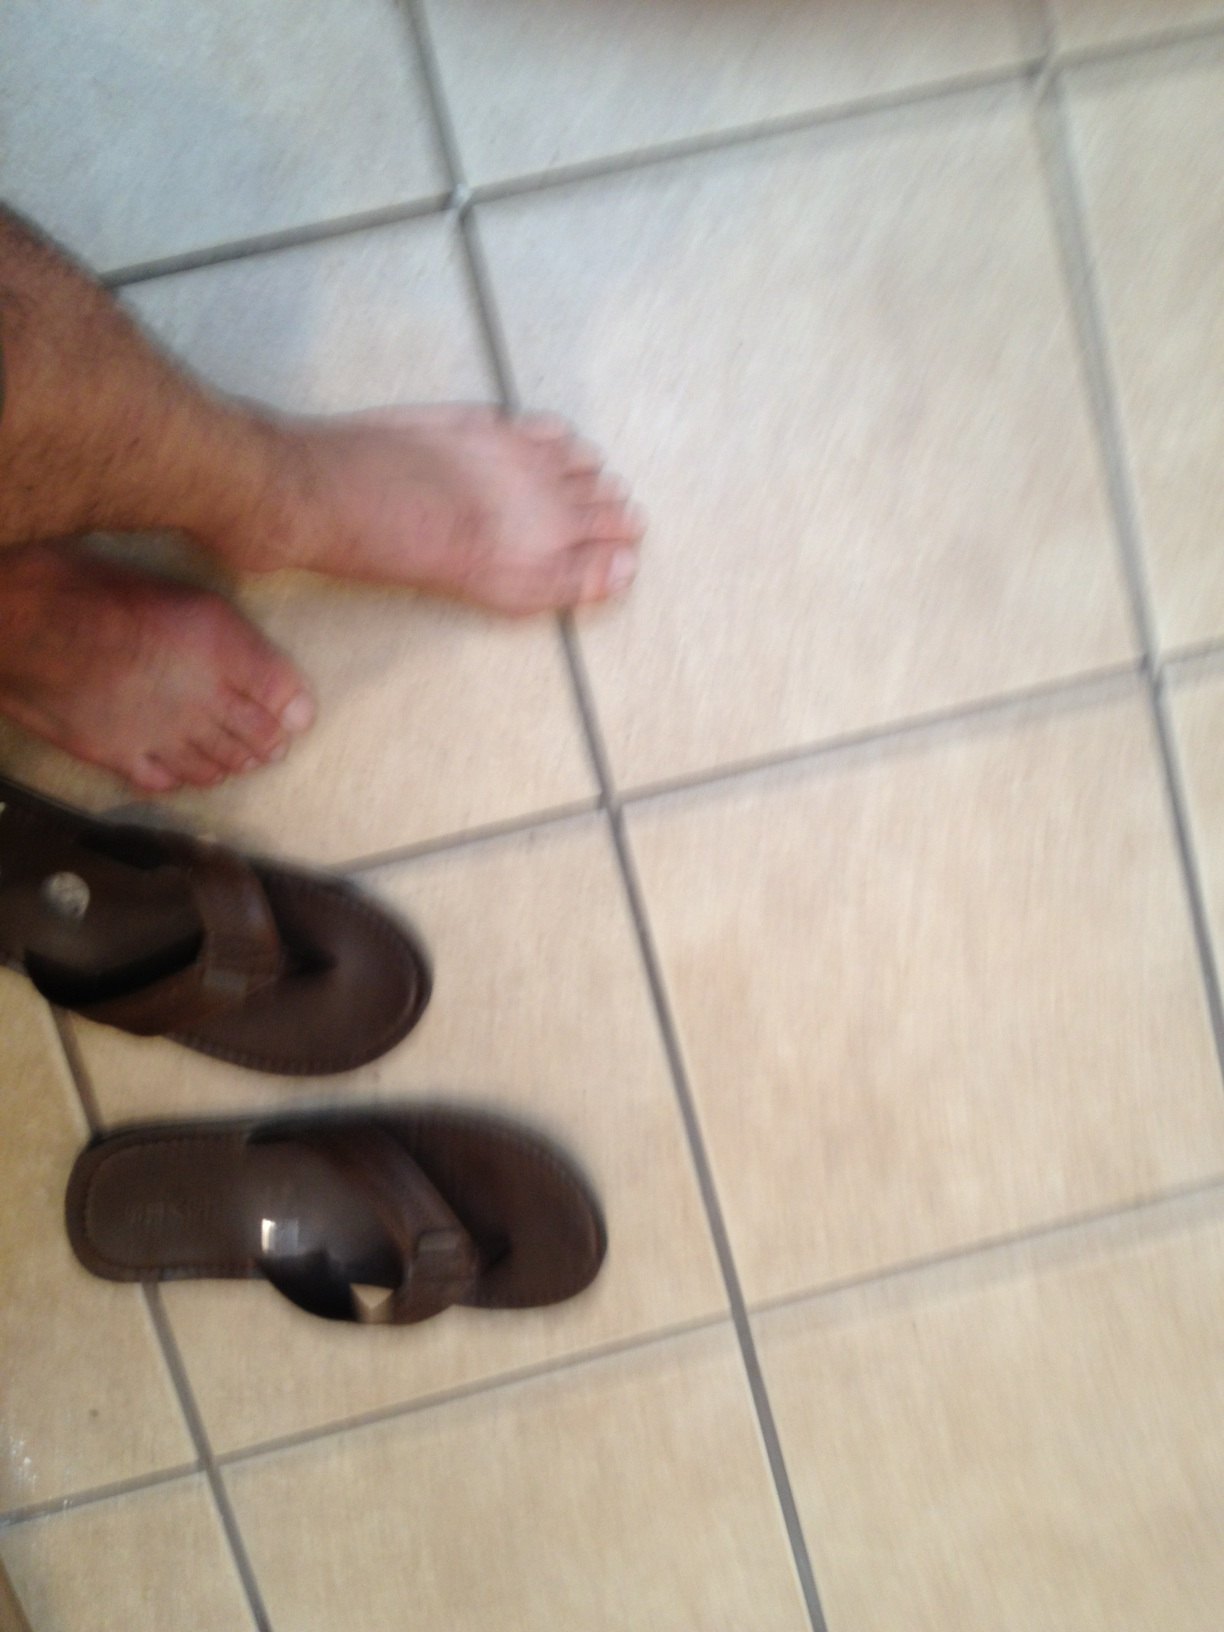Can you tell the possible material of these flip flops? These flip flops appear to be made primarily of rubber, a common material for such footwear. Rubber is chosen for its durability, water resistance, and ability to provide a good grip on various surfaces. 